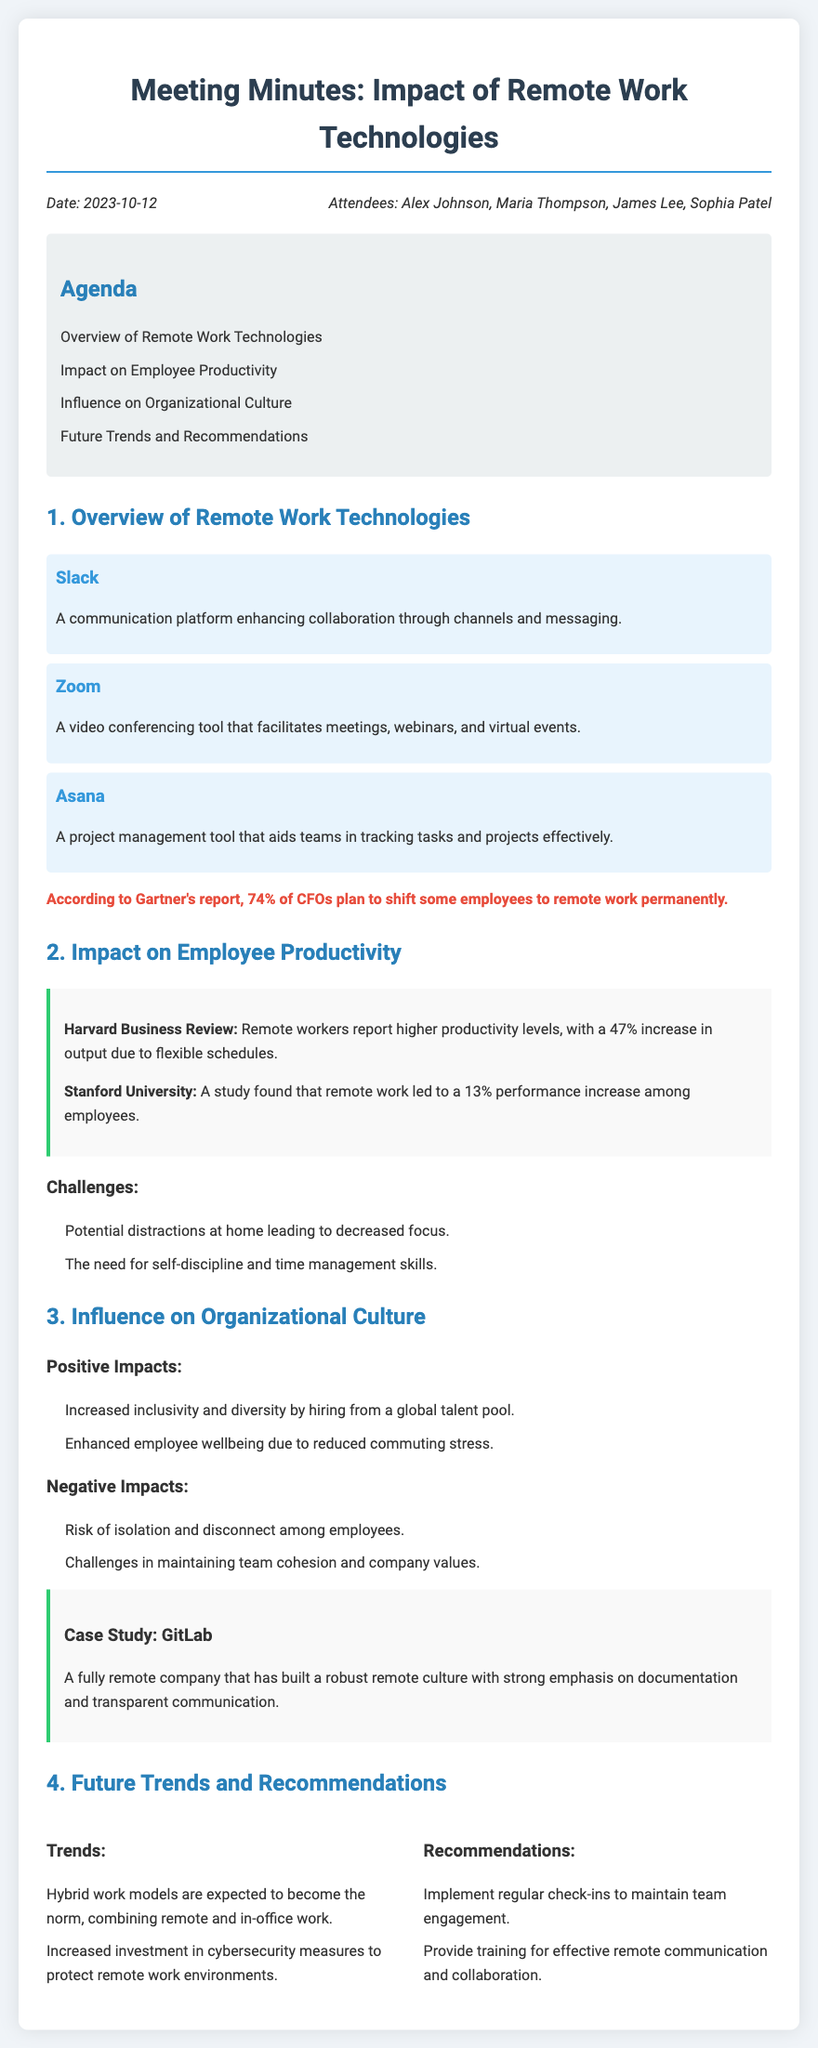What is the date of the meeting? The date of the meeting is stated in the document under the date-attendees section.
Answer: 2023-10-12 Who conducted the case study mentioned in the meeting? The case study mentioned in the document is about a specific company that is referenced.
Answer: GitLab What percentage of CFOs plan to shift some employees to remote work permanently? The document includes a statistic that reflects the planning intentions of CFOs regarding remote work.
Answer: 74% What is one of the positive impacts of remote work on organizational culture? The document lists positive impacts under the influence on organizational culture section.
Answer: Increased inclusivity and diversity What is a challenge for employees working remotely? The document outlines challenges under the impact on employee productivity section.
Answer: Potential distractions at home What is one recommended trend mentioned for future work structures? The document discusses future trends in a specific section.
Answer: Hybrid work models How many attendees were present at the meeting? The document includes the names of attendees in the date-attendees section.
Answer: Four What is the source of the statistic regarding remote worker productivity? The document cites specific reports that provide evidence for the claims made about productivity.
Answer: Harvard Business Review 